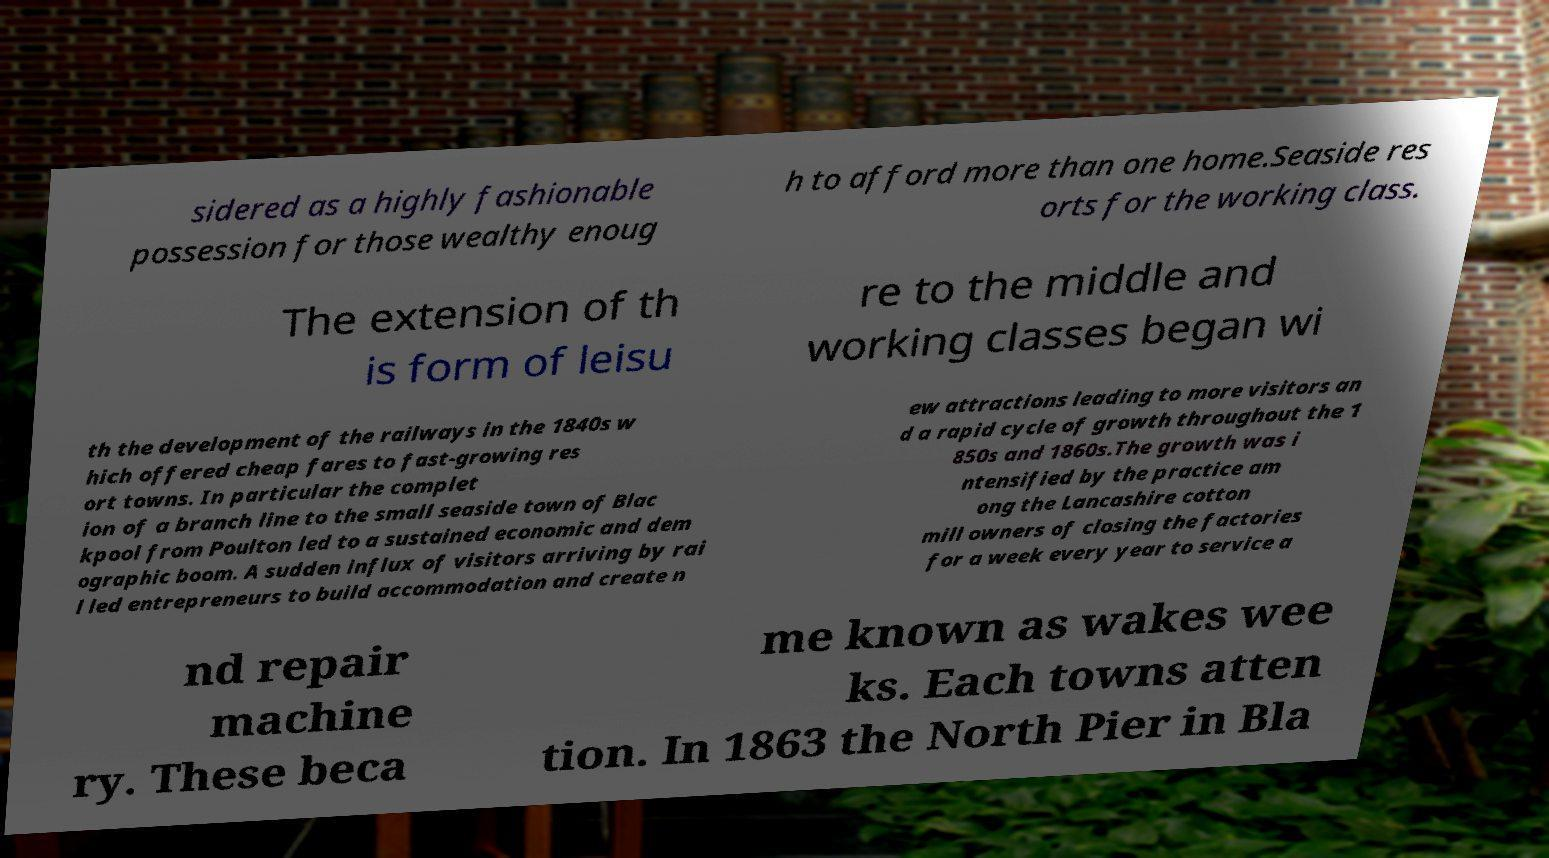What messages or text are displayed in this image? I need them in a readable, typed format. sidered as a highly fashionable possession for those wealthy enoug h to afford more than one home.Seaside res orts for the working class. The extension of th is form of leisu re to the middle and working classes began wi th the development of the railways in the 1840s w hich offered cheap fares to fast-growing res ort towns. In particular the complet ion of a branch line to the small seaside town of Blac kpool from Poulton led to a sustained economic and dem ographic boom. A sudden influx of visitors arriving by rai l led entrepreneurs to build accommodation and create n ew attractions leading to more visitors an d a rapid cycle of growth throughout the 1 850s and 1860s.The growth was i ntensified by the practice am ong the Lancashire cotton mill owners of closing the factories for a week every year to service a nd repair machine ry. These beca me known as wakes wee ks. Each towns atten tion. In 1863 the North Pier in Bla 